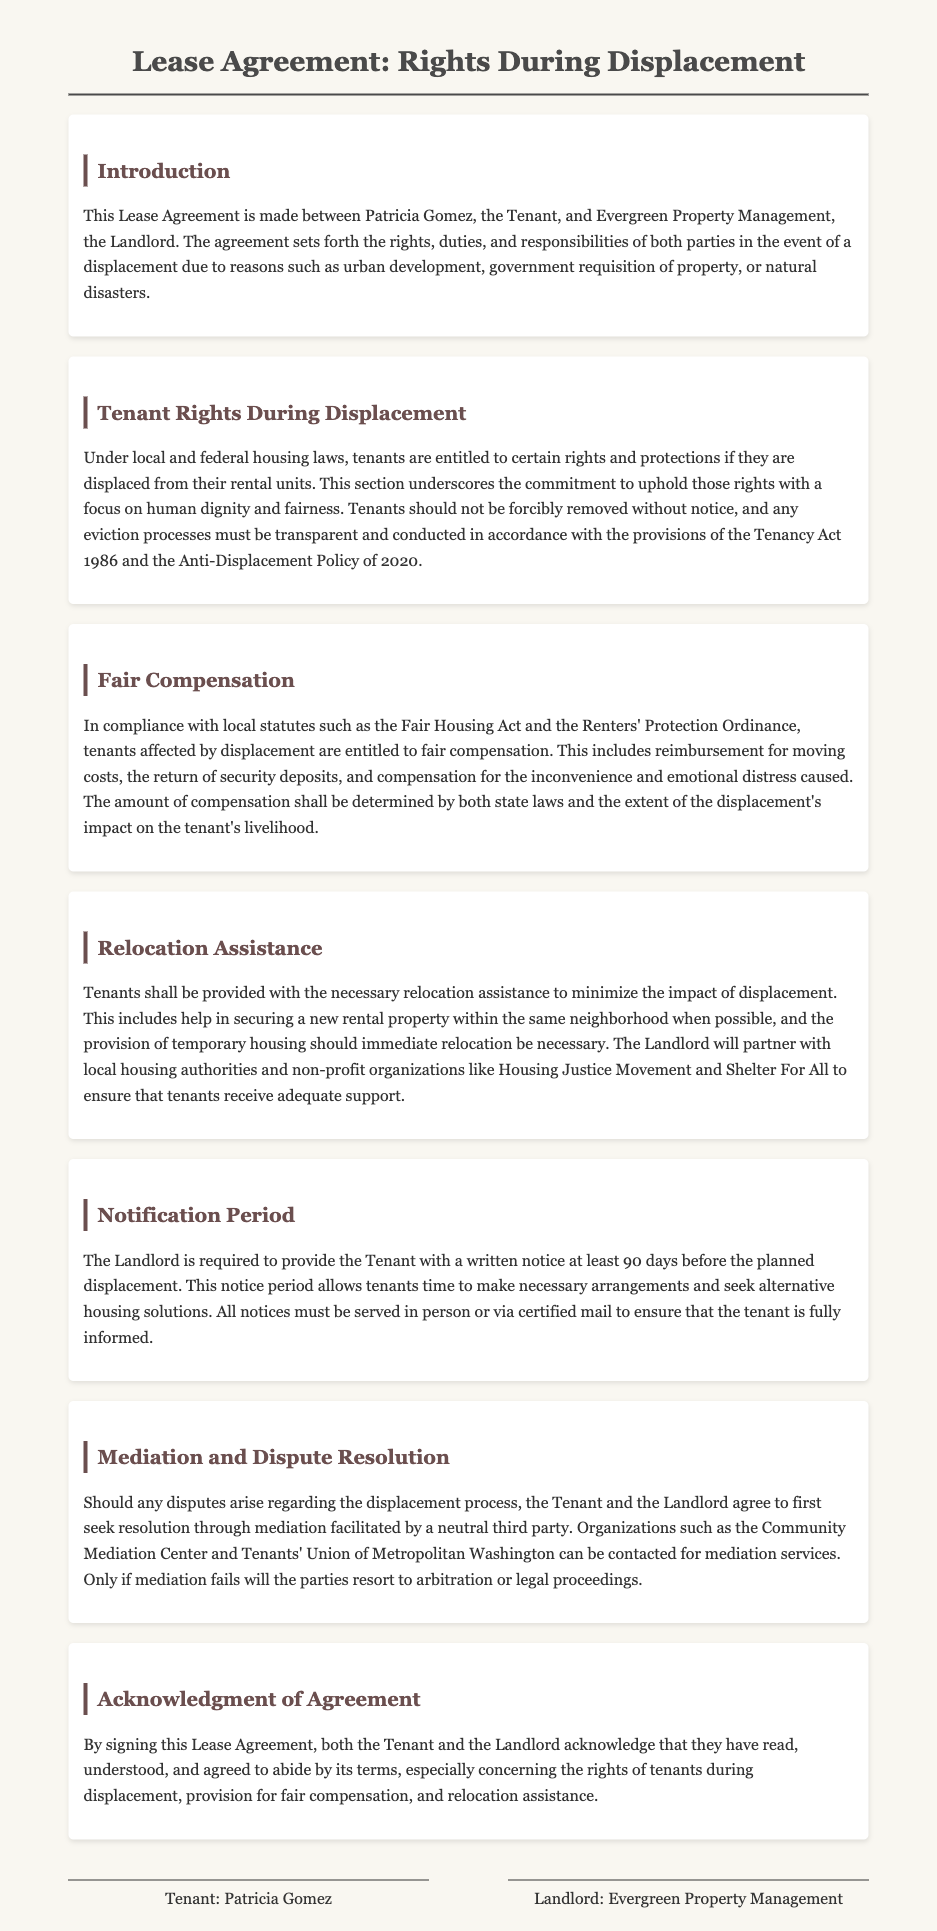what is the name of the Tenant? The document specifies that the Tenant's name is Patricia Gomez.
Answer: Patricia Gomez what is the minimum notice period required before displacement? The document states that the Landlord must provide at least 90 days written notice before the planned displacement.
Answer: 90 days which organization helps with mediation? The document mentions that the Community Mediation Center can be contacted for mediation services.
Answer: Community Mediation Center what type of assistance are tenants entitled to receive during displacement? The document outlines that tenants are entitled to relocation assistance and help in securing a new rental property.
Answer: relocation assistance which local statute is referenced regarding fair compensation? The Fair Housing Act is mentioned in connection with fair compensation for tenants affected by displacement.
Answer: Fair Housing Act what is the purpose of the acknowledgment section in the agreement? The purpose is for both parties to confirm they have read, understood, and agreed to the terms, particularly regarding displacement rights.
Answer: confirm understanding who is the Landlord in this Lease Agreement? The Lease Agreement identifies Evergreen Property Management as the Landlord.
Answer: Evergreen Property Management what are tenants entitled to regarding moving costs? Tenants are entitled to reimbursement for moving costs as part of fair compensation during displacement.
Answer: reimbursement for moving costs what must all notices be served via? The document states that all notices must be served in person or via certified mail.
Answer: certified mail 